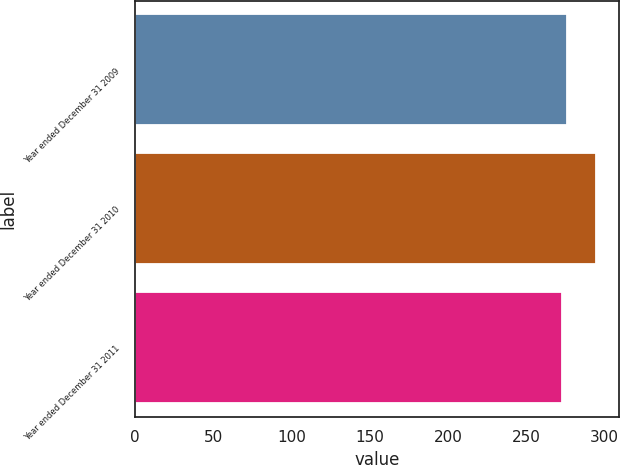<chart> <loc_0><loc_0><loc_500><loc_500><bar_chart><fcel>Year ended December 31 2009<fcel>Year ended December 31 2010<fcel>Year ended December 31 2011<nl><fcel>276<fcel>295<fcel>273<nl></chart> 